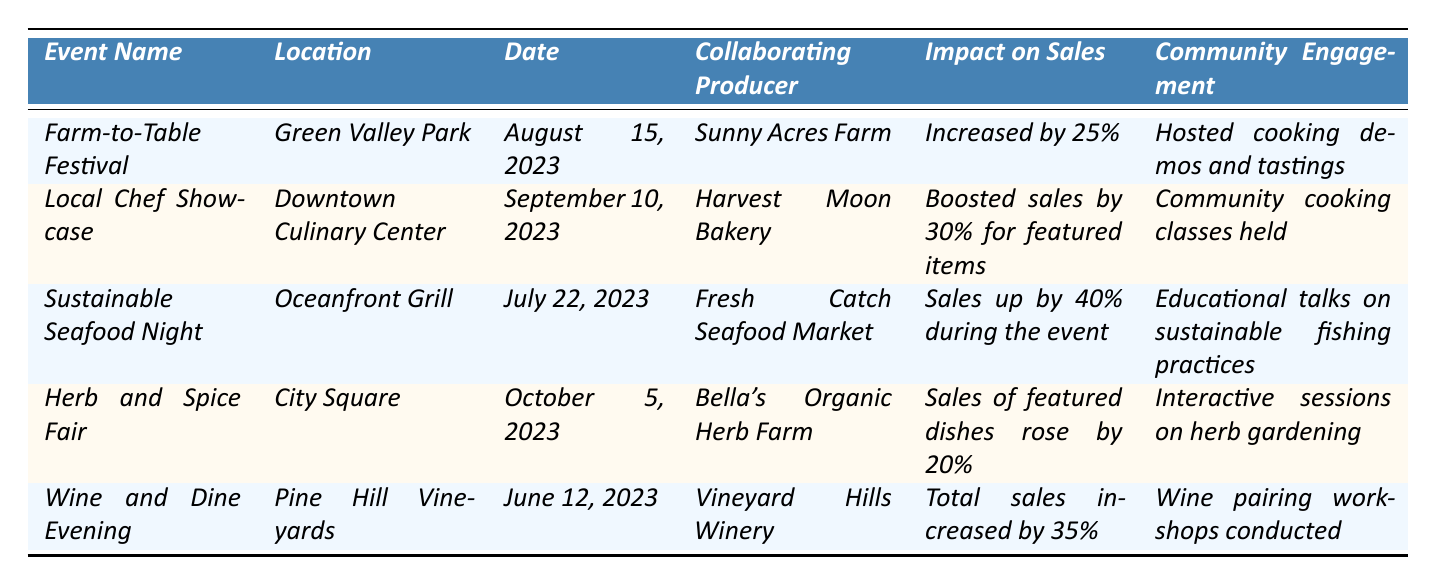What is the location of the Farm-to-Table Festival? The table provides a specific row for the Farm-to-Table Festival, which shows its location as Green Valley Park.
Answer: Green Valley Park Which event had the highest impact on sales? By comparing the impact on sales across all events, Sustainable Seafood Night shows an increase of 40%, which is the highest percentage listed.
Answer: Sustainable Seafood Night Did the Wine and Dine Evening include any community engagement activities? The table lists that the Wine and Dine Evening included wine pairing workshops, indicating that there were community engagement activities involved.
Answer: Yes What was the average increase in sales across all five collaboration events? The sales impacts are 25%, 30%, 40%, 20%, and 35%. To find the average, sum these values (25 + 30 + 40 + 20 + 35) = 150, then divide by 5, resulting in an average of 30%.
Answer: 30% Which collaborating producer was featured in the Herb and Spice Fair? The specifics in the Herb and Spice Fair entry in the table list Bella's Organic Herb Farm as the collaborating producer.
Answer: Bella's Organic Herb Farm How many events listed took place before August 2023? Checking the dates, the events that occurred before August 2023 are the Wine and Dine Evening (June 12, 2023) and the Sustainable Seafood Night (July 22, 2023). Therefore, there are 2 events.
Answer: 2 Was there any community engagement related to educational talks in the events listed? The Sustainable Seafood Night entry mentions educational talks on sustainable fishing practices, indicating such a community engagement activity was present.
Answer: Yes Which event took place on September 10, 2023, and what was its impact on sales? Referring to the table, the Local Chef Showcase took place on September 10, 2023, and had an impact on sales that boosted them by 30% for featured items.
Answer: Local Chef Showcase; boosted sales by 30% How do the community engagement activities vary among the events based on the table? By looking at the community engagement column, we notice that the activities range from cooking demos and tastings to educational talks and interactive sessions, showing a variety of engagement themes centered around cooking and sustainability.
Answer: They vary in type and focus on cooking and sustainability Which event had a collaboration with a family-run farm and what was the sales impact? Upon inspection, the Farm-to-Table Festival collaborated with Sunny Acres Farm and resulted in a sales increase of 25%.
Answer: Farm-to-Table Festival; increased by 25% 